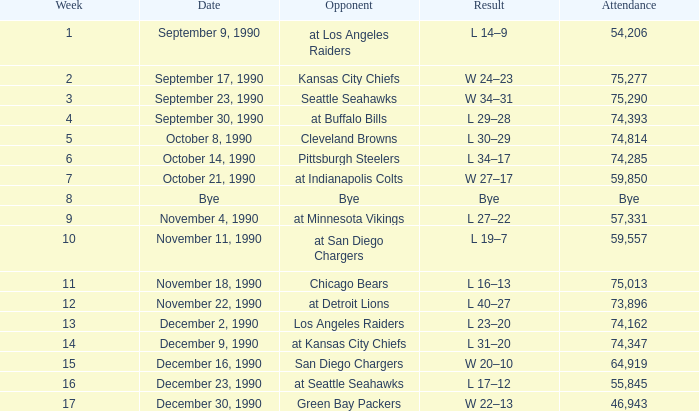Parse the full table. {'header': ['Week', 'Date', 'Opponent', 'Result', 'Attendance'], 'rows': [['1', 'September 9, 1990', 'at Los Angeles Raiders', 'L 14–9', '54,206'], ['2', 'September 17, 1990', 'Kansas City Chiefs', 'W 24–23', '75,277'], ['3', 'September 23, 1990', 'Seattle Seahawks', 'W 34–31', '75,290'], ['4', 'September 30, 1990', 'at Buffalo Bills', 'L 29–28', '74,393'], ['5', 'October 8, 1990', 'Cleveland Browns', 'L 30–29', '74,814'], ['6', 'October 14, 1990', 'Pittsburgh Steelers', 'L 34–17', '74,285'], ['7', 'October 21, 1990', 'at Indianapolis Colts', 'W 27–17', '59,850'], ['8', 'Bye', 'Bye', 'Bye', 'Bye'], ['9', 'November 4, 1990', 'at Minnesota Vikings', 'L 27–22', '57,331'], ['10', 'November 11, 1990', 'at San Diego Chargers', 'L 19–7', '59,557'], ['11', 'November 18, 1990', 'Chicago Bears', 'L 16–13', '75,013'], ['12', 'November 22, 1990', 'at Detroit Lions', 'L 40–27', '73,896'], ['13', 'December 2, 1990', 'Los Angeles Raiders', 'L 23–20', '74,162'], ['14', 'December 9, 1990', 'at Kansas City Chiefs', 'L 31–20', '74,347'], ['15', 'December 16, 1990', 'San Diego Chargers', 'W 20–10', '64,919'], ['16', 'December 23, 1990', 'at Seattle Seahawks', 'L 17–12', '55,845'], ['17', 'December 30, 1990', 'Green Bay Packers', 'W 22–13', '46,943']]} How many weeks was there an attendance of 74,347? 14.0. 